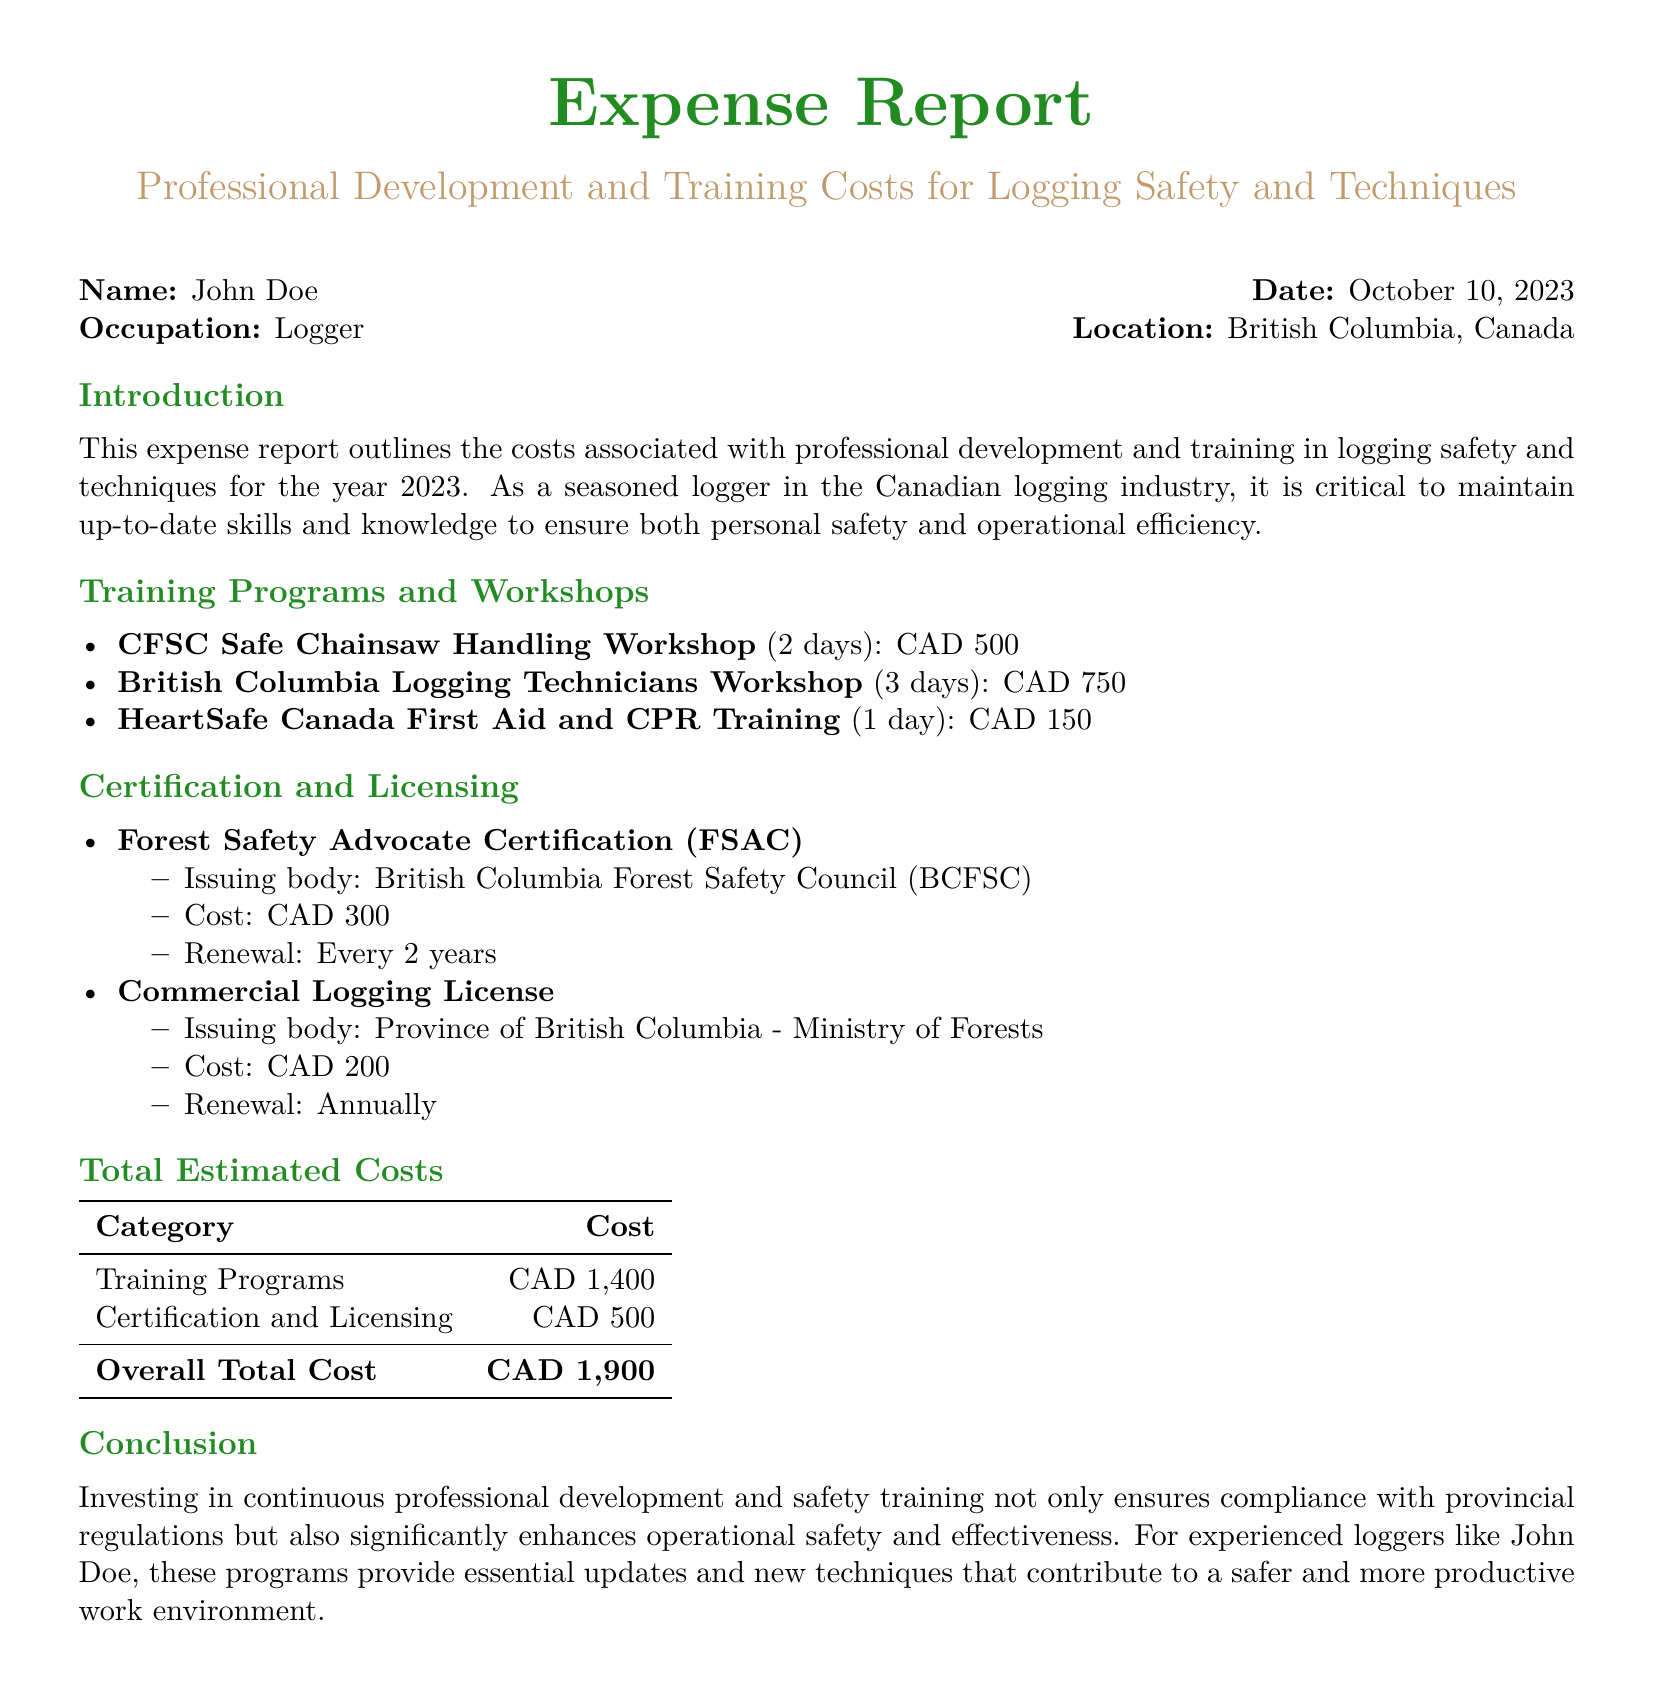what is the total cost for training programs? The total cost for training programs is listed in the Total Estimated Costs section of the document as CAD 1,400.
Answer: CAD 1,400 how much does the Commercial Logging License cost? The cost for the Commercial Logging License is found under Certification and Licensing and is stated as CAD 200.
Answer: CAD 200 how often does the Forest Safety Advocate Certification need to be renewed? The renewal period for the Forest Safety Advocate Certification is mentioned in the Certification and Licensing section, stating it is every 2 years.
Answer: Every 2 years what is the name of the workshop focused on chainsaw handling? The name of the workshop focused on chainsaw handling is specified in the Training Programs and Workshops section as CFSC Safe Chainsaw Handling Workshop.
Answer: CFSC Safe Chainsaw Handling Workshop what is the total estimated cost reported in the document? The overall total cost, summarizing both training and certification, is provided in the Total Estimated Costs section as CAD 1,900.
Answer: CAD 1,900 what type of training does HeartSafe Canada provide? HeartSafe Canada provides First Aid and CPR Training as mentioned in the Training Programs and Workshops section.
Answer: First Aid and CPR Training who issues the Commercial Logging License? The issuing body for the Commercial Logging License is described under Certification and Licensing as the Province of British Columbia - Ministry of Forests.
Answer: Province of British Columbia - Ministry of Forests how many days is the British Columbia Logging Technicians Workshop? The duration of the British Columbia Logging Technicians Workshop is specified in the document as 3 days.
Answer: 3 days 